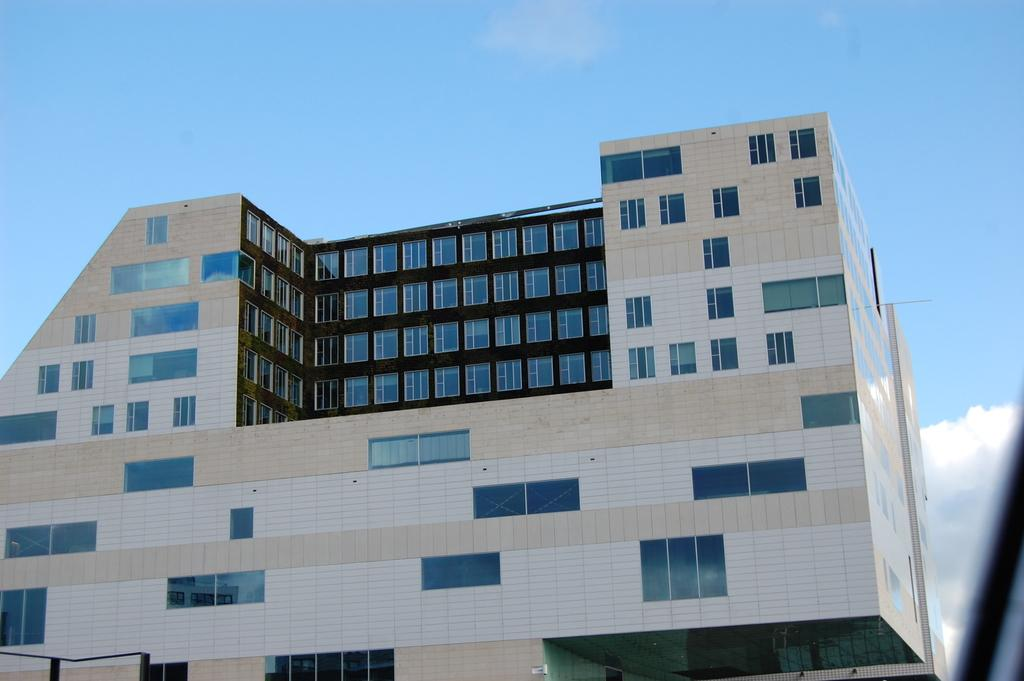What is the main structure in the front of the image? There is a building in the front of the image. What feature can be observed on the building? The building has multiple glass windows. What can be seen in the background of the image? There are clouds and the sky visible in the background of the image. What type of drug is being sold in the building in the image? There is no indication in the image that the building is selling any drugs, and therefore no such activity can be observed. 